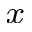<formula> <loc_0><loc_0><loc_500><loc_500>_ { x }</formula> 